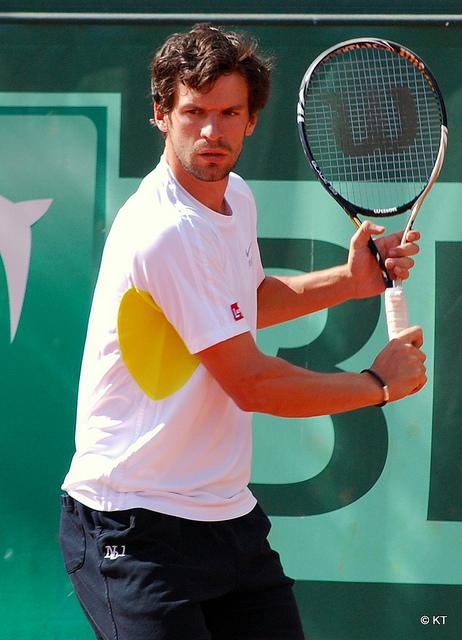What athlete is this?
Give a very brief answer. Tennis player. What color are the man's pants?
Keep it brief. Black. Who is the sponsor of the US OPEN SERIES?
Quick response, please. Wilson. What brand of racket is he using?
Concise answer only. Wilson. Is he actually playing?
Short answer required. Yes. 